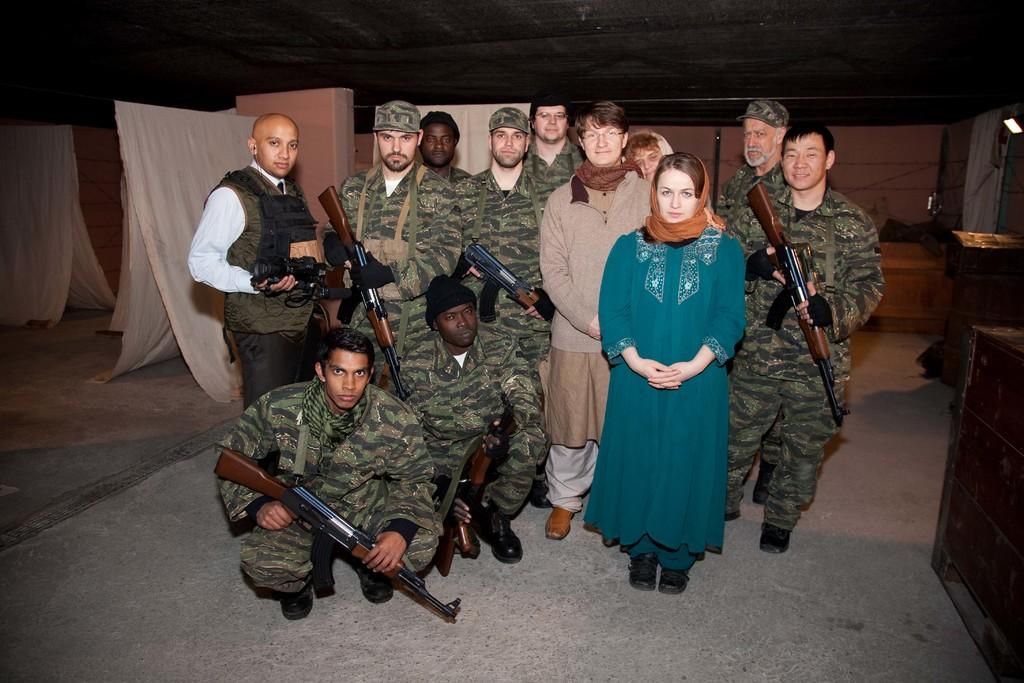What is the main subject of the image? The main subject of the image is a group of people. What are some of the people in the group holding? Some people in the group are holding rifles. What can be seen in the background of the image? Clothes and other objects are visible in the background of the image. What type of sound can be heard coming from the pump in the garden in the image? There is no pump or garden present in the image, so it's not possible to determine what, if any, sound might be heard. 